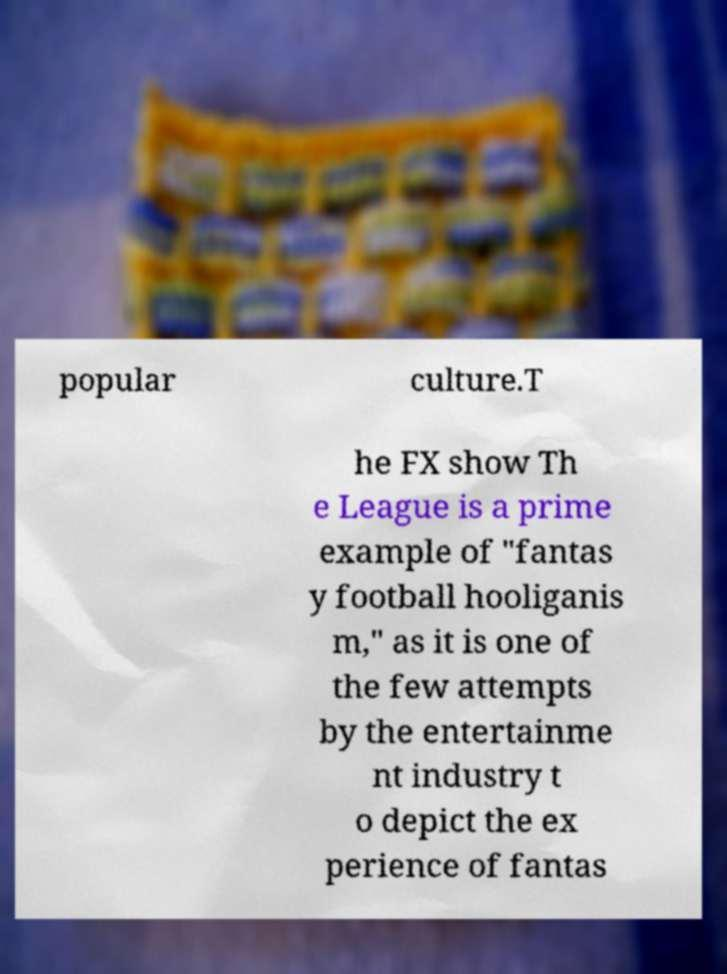I need the written content from this picture converted into text. Can you do that? popular culture.T he FX show Th e League is a prime example of "fantas y football hooliganis m," as it is one of the few attempts by the entertainme nt industry t o depict the ex perience of fantas 